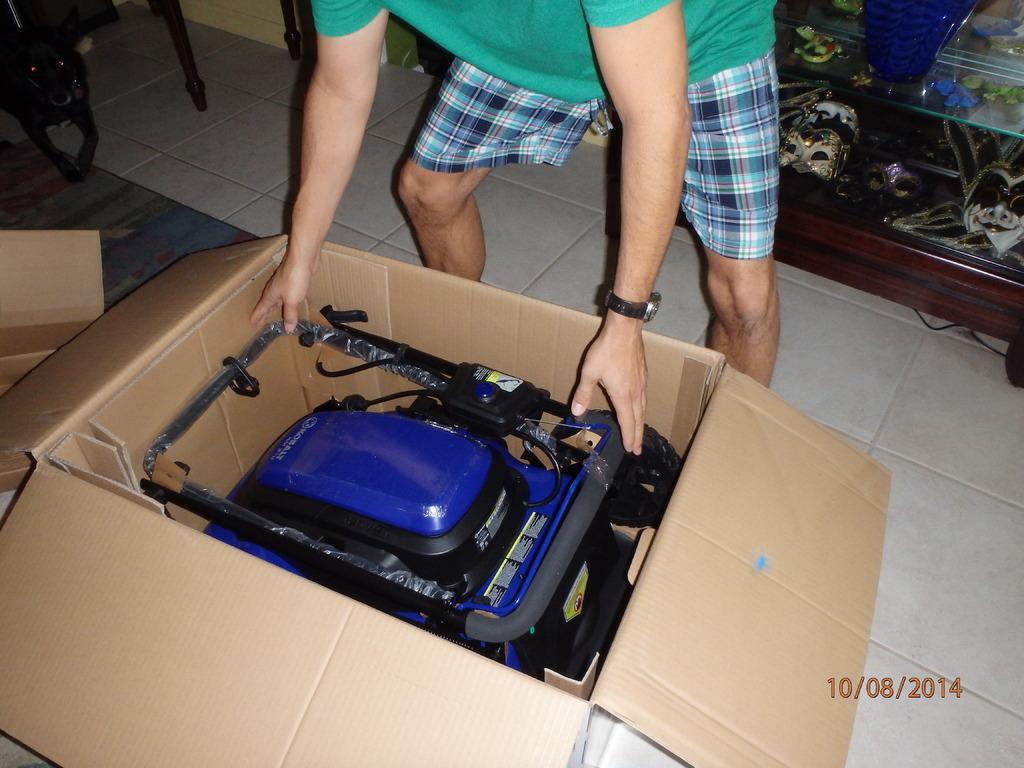Describe this image in one or two sentences. In this picture, we see a carton box in which toy vehicle is placed. It is in blue color. Beside that, the man in green T-shirt is trying to hold that vehicle. Behind him, we see a cupboard and in the left top of the picture, we see a table and chair. This picture is clicked inside the room. 